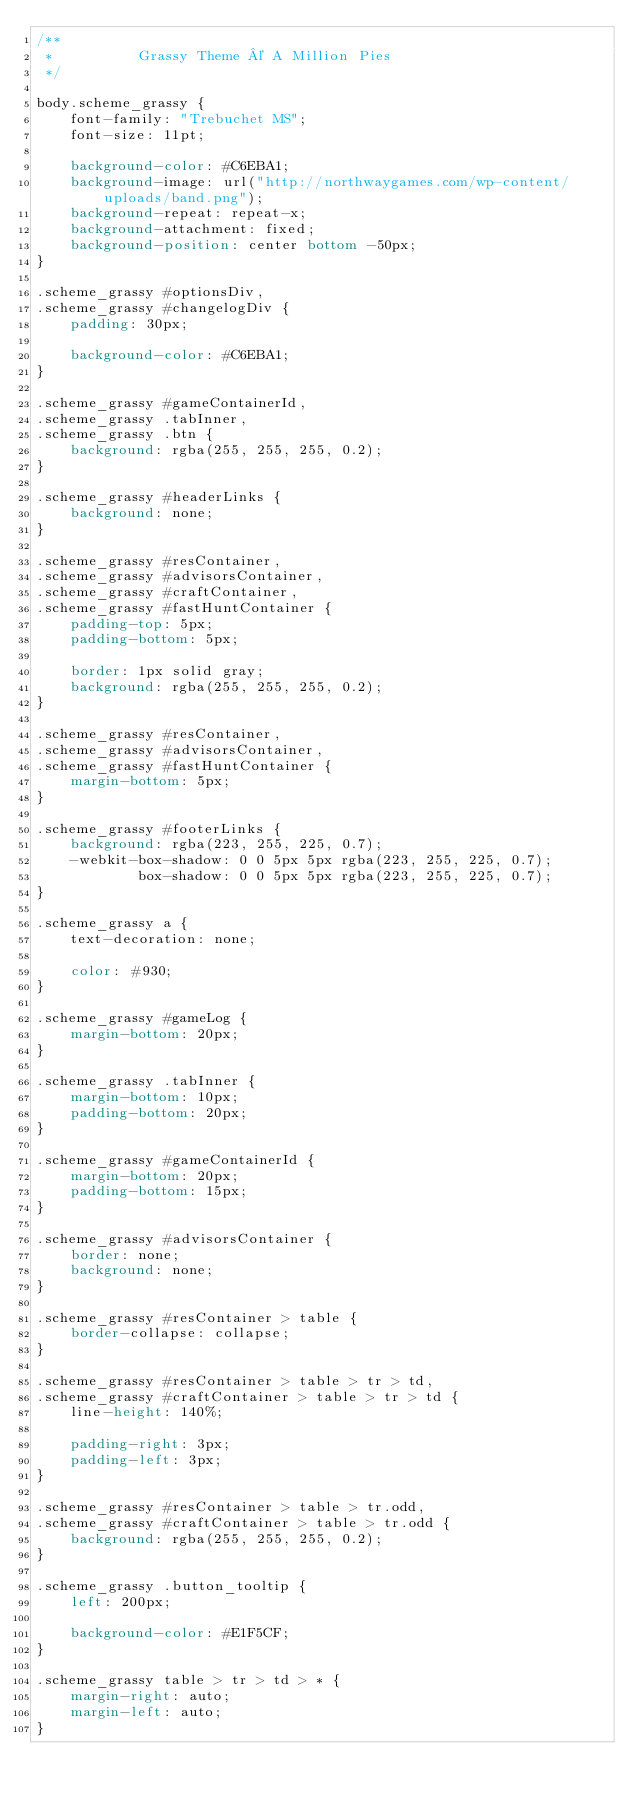<code> <loc_0><loc_0><loc_500><loc_500><_CSS_>/**
 *			Grassy Theme © A Million Pies
 */

body.scheme_grassy {
	font-family: "Trebuchet MS";
	font-size: 11pt;

	background-color: #C6EBA1;
	background-image: url("http://northwaygames.com/wp-content/uploads/band.png");
	background-repeat: repeat-x;
	background-attachment: fixed;
	background-position: center bottom -50px;
}

.scheme_grassy #optionsDiv,
.scheme_grassy #changelogDiv {
	padding: 30px;

	background-color: #C6EBA1;
}

.scheme_grassy #gameContainerId,
.scheme_grassy .tabInner,
.scheme_grassy .btn {
	background: rgba(255, 255, 255, 0.2);
}

.scheme_grassy #headerLinks {
	background: none;
}

.scheme_grassy #resContainer,
.scheme_grassy #advisorsContainer,
.scheme_grassy #craftContainer,
.scheme_grassy #fastHuntContainer {
	padding-top: 5px;
	padding-bottom: 5px;

	border: 1px solid gray;
	background: rgba(255, 255, 255, 0.2);
}

.scheme_grassy #resContainer,
.scheme_grassy #advisorsContainer,
.scheme_grassy #fastHuntContainer {
	margin-bottom: 5px;
}

.scheme_grassy #footerLinks {
	background: rgba(223, 255, 225, 0.7);
	-webkit-box-shadow: 0 0 5px 5px rgba(223, 255, 225, 0.7);
			box-shadow: 0 0 5px 5px rgba(223, 255, 225, 0.7);
}

.scheme_grassy a {
	text-decoration: none;

	color: #930;
}

.scheme_grassy #gameLog {
	margin-bottom: 20px;
}

.scheme_grassy .tabInner {
	margin-bottom: 10px;
	padding-bottom: 20px;
}

.scheme_grassy #gameContainerId {
	margin-bottom: 20px;
	padding-bottom: 15px;
}

.scheme_grassy #advisorsContainer {
	border: none;
	background: none;
}

.scheme_grassy #resContainer > table {
	border-collapse: collapse;
}

.scheme_grassy #resContainer > table > tr > td,
.scheme_grassy #craftContainer > table > tr > td {
	line-height: 140%;

	padding-right: 3px;
	padding-left: 3px;
}

.scheme_grassy #resContainer > table > tr.odd,
.scheme_grassy #craftContainer > table > tr.odd {
	background: rgba(255, 255, 255, 0.2);
}

.scheme_grassy .button_tooltip {
	left: 200px;

	background-color: #E1F5CF;
}

.scheme_grassy table > tr > td > * {
	margin-right: auto;
	margin-left: auto;
}</code> 